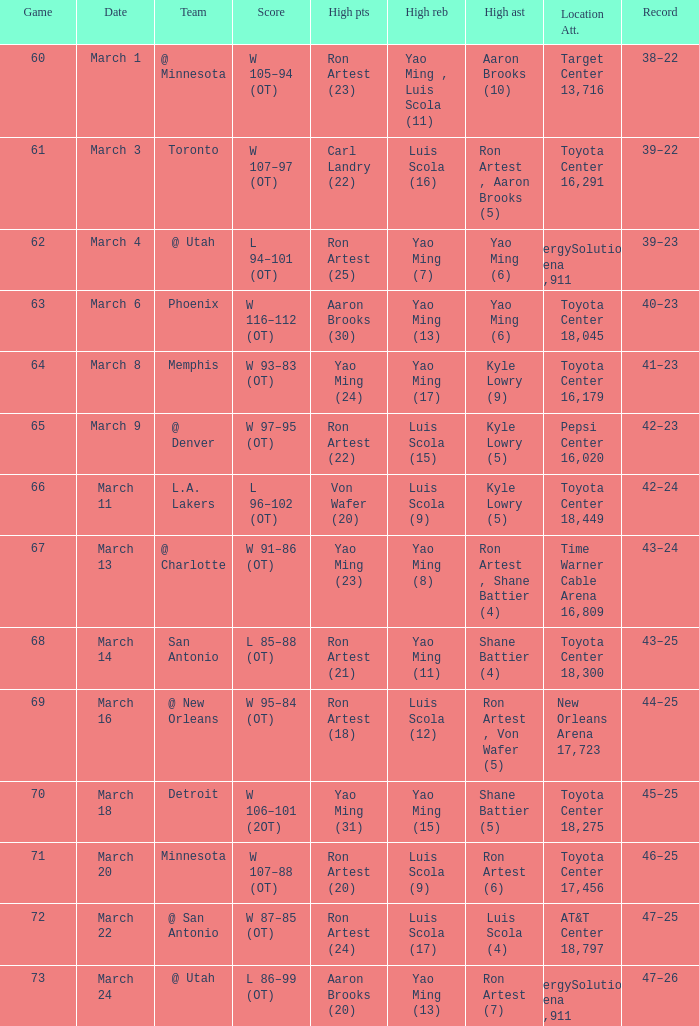Who had the most poinst in game 72? Ron Artest (24). 